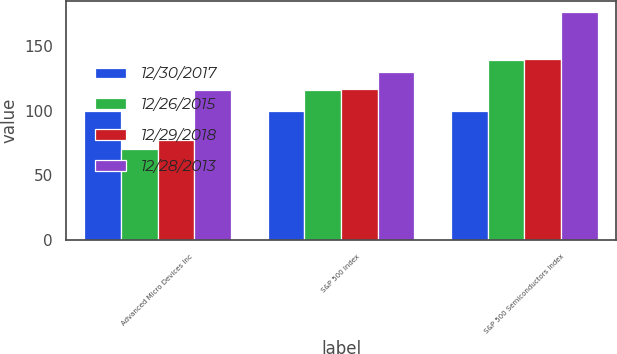Convert chart to OTSL. <chart><loc_0><loc_0><loc_500><loc_500><stacked_bar_chart><ecel><fcel>Advanced Micro Devices Inc<fcel>S&P 500 Index<fcel>S&P 500 Semiconductors Index<nl><fcel>12/30/2017<fcel>100<fcel>100<fcel>100<nl><fcel>12/26/2015<fcel>70.11<fcel>115.76<fcel>139.35<nl><fcel>12/29/2018<fcel>77.25<fcel>116.64<fcel>140<nl><fcel>12/28/2013<fcel>115.76<fcel>129.55<fcel>175.9<nl></chart> 